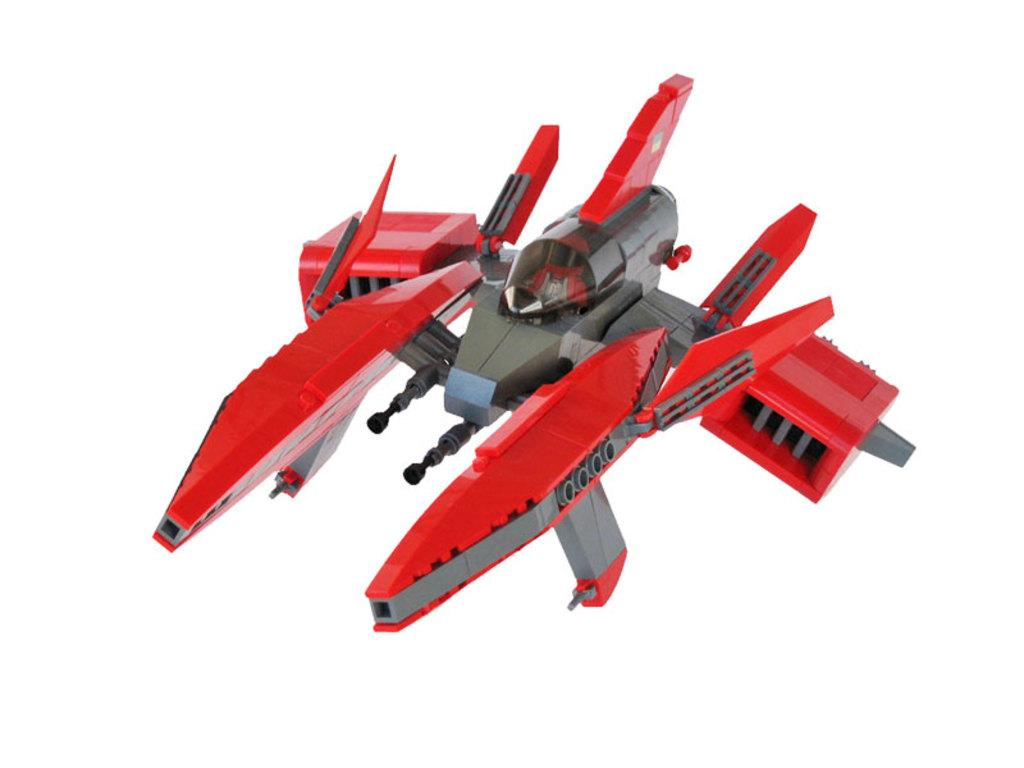What is the main object in the image? There is a toy in the image. Can you describe the colors of the toy? The toy has a red and gray color combination. Where is the toy located in the image? The toy is on a surface. What is the color of the background in the image? The background of the image is white. What type of fireman is depicted in the image? There is no fireman present in the image; it features a toy with a red and gray color combination. Can you tell me how the minister is feeling in the image? There is no minister present in the image; it features a toy on a surface with a white background. 